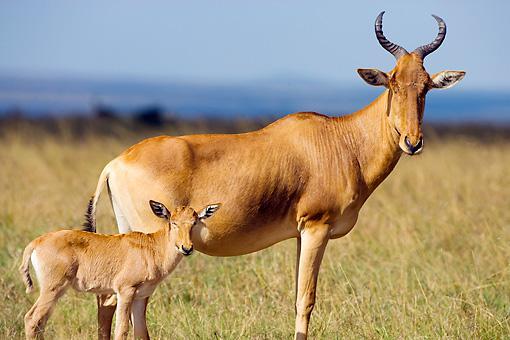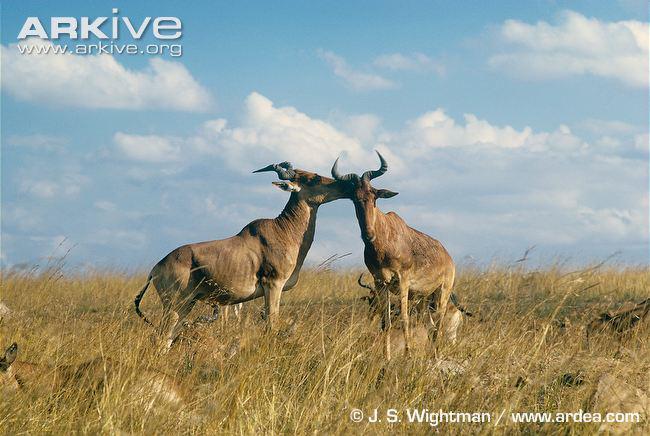The first image is the image on the left, the second image is the image on the right. Examine the images to the left and right. Is the description "There are baby antelope in the image on the left." accurate? Answer yes or no. Yes. The first image is the image on the left, the second image is the image on the right. Evaluate the accuracy of this statement regarding the images: "One of the images includes a single animal.". Is it true? Answer yes or no. No. 